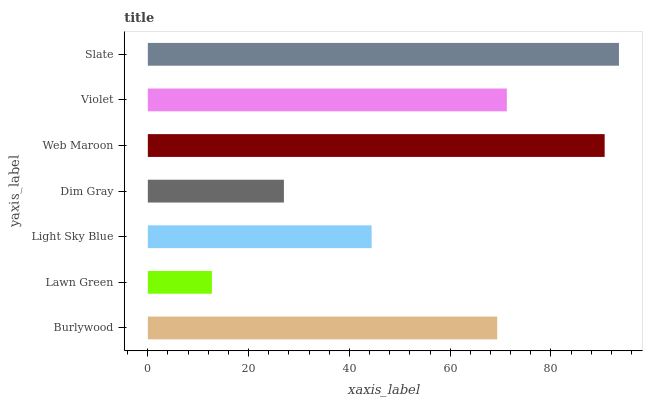Is Lawn Green the minimum?
Answer yes or no. Yes. Is Slate the maximum?
Answer yes or no. Yes. Is Light Sky Blue the minimum?
Answer yes or no. No. Is Light Sky Blue the maximum?
Answer yes or no. No. Is Light Sky Blue greater than Lawn Green?
Answer yes or no. Yes. Is Lawn Green less than Light Sky Blue?
Answer yes or no. Yes. Is Lawn Green greater than Light Sky Blue?
Answer yes or no. No. Is Light Sky Blue less than Lawn Green?
Answer yes or no. No. Is Burlywood the high median?
Answer yes or no. Yes. Is Burlywood the low median?
Answer yes or no. Yes. Is Lawn Green the high median?
Answer yes or no. No. Is Lawn Green the low median?
Answer yes or no. No. 